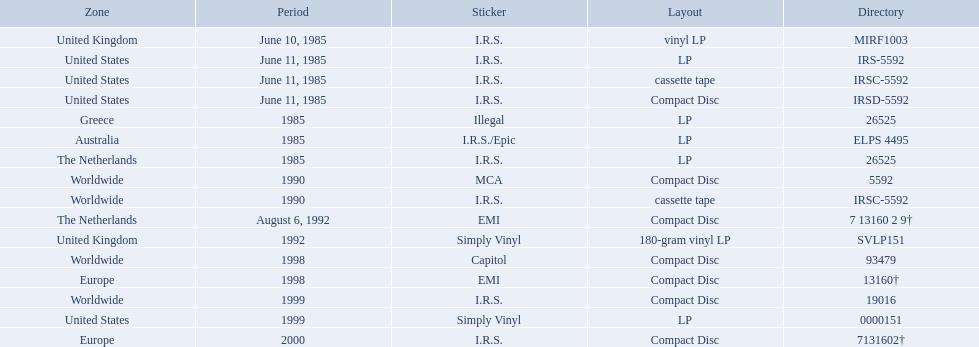In which regions was the fables of the reconstruction album released? United Kingdom, United States, United States, United States, Greece, Australia, The Netherlands, Worldwide, Worldwide, The Netherlands, United Kingdom, Worldwide, Europe, Worldwide, United States, Europe. And what were the release dates for those regions? June 10, 1985, June 11, 1985, June 11, 1985, June 11, 1985, 1985, 1985, 1985, 1990, 1990, August 6, 1992, 1992, 1998, 1998, 1999, 1999, 2000. And which region was listed after greece in 1985? Australia. Which dates were their releases by fables of the reconstruction? June 10, 1985, June 11, 1985, June 11, 1985, June 11, 1985, 1985, 1985, 1985, 1990, 1990, August 6, 1992, 1992, 1998, 1998, 1999, 1999, 2000. Which of these are in 1985? June 10, 1985, June 11, 1985, June 11, 1985, June 11, 1985, 1985, 1985, 1985. What regions were there releases on these dates? United Kingdom, United States, United States, United States, Greece, Australia, The Netherlands. Which of these are not greece? United Kingdom, United States, United States, United States, Australia, The Netherlands. Which of these regions have two labels listed? Australia. 